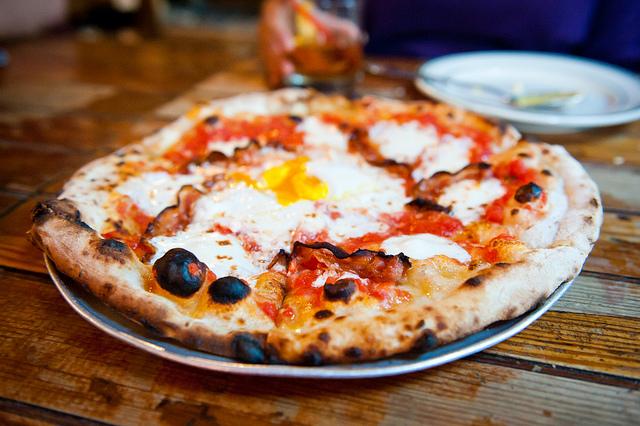What are the black things?
Keep it brief. Olives. Is it a New York style pizza?
Short answer required. Yes. What color is the napkin?
Answer briefly. White. Has any of the pizza been eaten?
Answer briefly. No. What is on the pizza?
Short answer required. Cheese. What kind of food is in the picture?
Quick response, please. Pizza. 